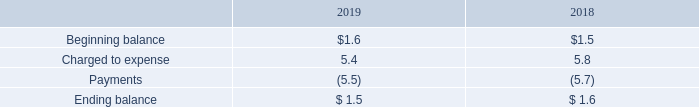Liability Insurance
The Company carries property, general liability, vehicle liability, directors’ and officers’ liability and workers’ compensation insurance. Additionally, the Company carries an umbrella liability policy to provide excess coverage over the underlying limits of the aforementioned primary policies.
The Company’s insurance programs for workers’ compensation, general liability, and employee related health care benefits are provided through high deductible or self-insured programs. Claims in excess of self-insurance levels are fully insured subject to policy limits. Accruals are based on historical claims experience, actual claims filed, and estimates of claims incurred but not reported.
The Company’s liabilities for unpaid and incurred, but not reported claims, for workers’ compensation, general liability, and health insurance at September 2019 and September 2018 was $1.5 million and $1.6 million, respectively. These amounts are included in accrued expenses in the accompanying Consolidated Balance Sheets. While the ultimate amount of claims incurred is dependent on future developments, in the Company’s opinion, recorded reserves are adequate to cover the future payment of claims previously incurred. However, it is possible that recorded reserves may not be adequate to cover the future payment of claims.
Adjustments, if any, to claims estimates previously recorded, resulting from actual claim payments, are reflected in operations in the periods in which such adjustments are known.
A summary of the activity in the Company’s self-insured liabilities reserve is set forth below (in millions):
What is the beginning balance in 2019 and 2018 respectively?
Answer scale should be: million. $1.6, $1.5. What are the company's respective liabilities for unpaid and incurred, but not reported claims, for workers’ compensation, general liability, and health insurance at September 2019 and September 2018? $1.5 million, $1.6 million. How are the company's insurance programs for workers’ compensation, general liability, and employee related health care benefits are provided? High deductible or self-insured programs. What is the percentage change in the beginning balance of the company's liability insurance between 2018 and 2019?
Answer scale should be: percent. (1.6 - 1.5)/1.5 
Answer: 6.67. What is the percentage change in the charged to expense value of the company's liability insurance between 2018 and 2019?
Answer scale should be: percent. (5.4 - 5.8)/5.8 
Answer: -6.9. What is the percentage change in the ending balance of the company's liability insurance between 2018 and 2019?
Answer scale should be: percent. (1.5 - 1.6)/1.6 
Answer: -6.25. 